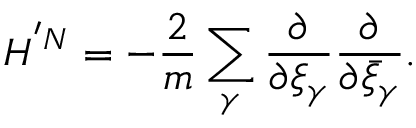<formula> <loc_0><loc_0><loc_500><loc_500>H ^ { ^ { \prime } N } = - \frac { 2 } { m } \sum _ { \gamma } \frac { \partial } { \partial \xi _ { \gamma } } \frac { \partial } { \partial \bar { \xi } _ { \gamma } } .</formula> 